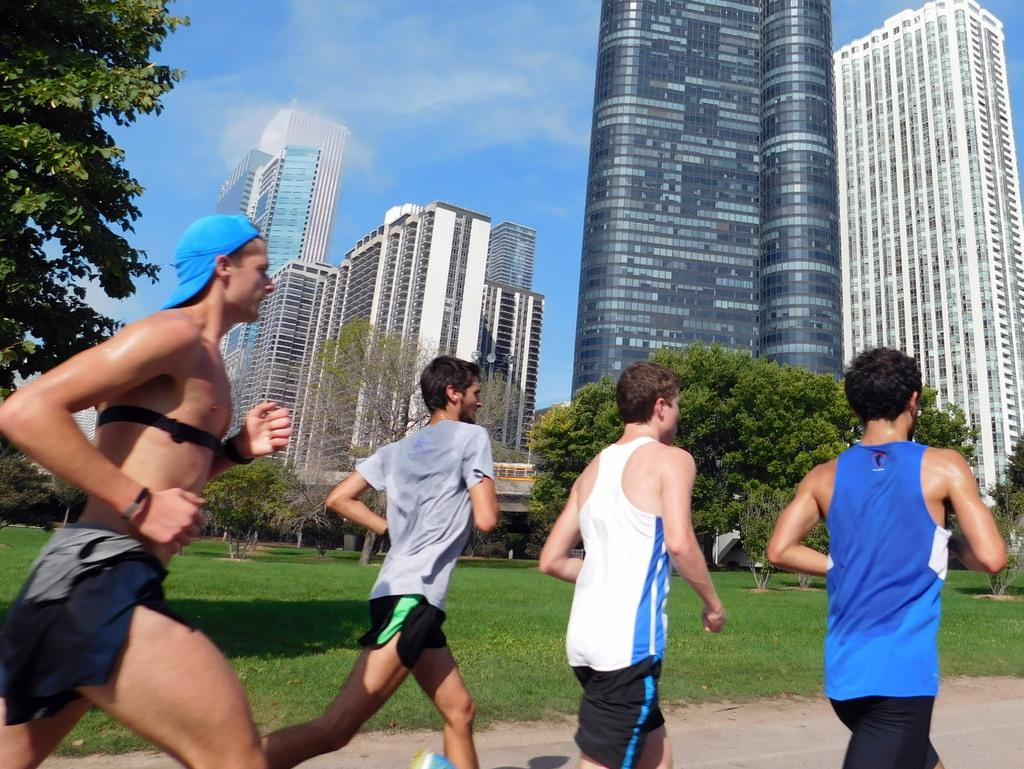What are the people in the image doing? There are people jogging on the road in the image. What is the surface they are jogging on? The ground is covered with grass. What can be seen in the background of the image? There are huge buildings in the background. What is the condition of the sky in the image? The sky is clear in the image. What type of yarn is being used by the joggers in the image? There is no yarn present in the image; the people are jogging on a grass-covered ground. What flavor of ice cream do the joggers believe they taste while running? There is no ice cream or mention of taste in the image; the people are jogging on a grass-covered ground. 